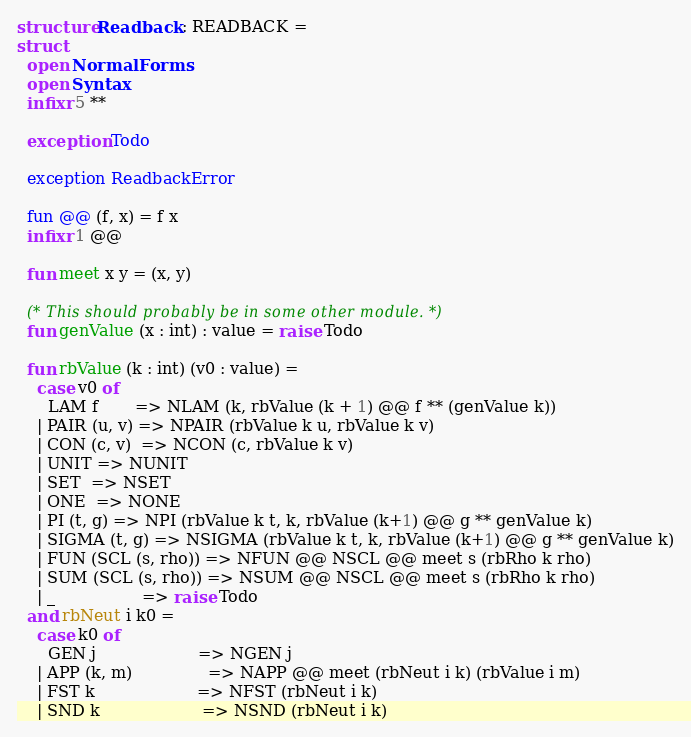<code> <loc_0><loc_0><loc_500><loc_500><_SML_>structure Readback : READBACK =
struct
  open NormalForms
  open Syntax
  infixr 5 **

  exception Todo

  exception ReadbackError

  fun @@ (f, x) = f x
  infixr 1 @@

  fun meet x y = (x, y)

  (* This should probably be in some other module. *)
  fun genValue (x : int) : value = raise Todo

  fun rbValue (k : int) (v0 : value) =
    case v0 of
      LAM f       => NLAM (k, rbValue (k + 1) @@ f ** (genValue k))
    | PAIR (u, v) => NPAIR (rbValue k u, rbValue k v)
    | CON (c, v)  => NCON (c, rbValue k v)
    | UNIT => NUNIT
    | SET  => NSET
    | ONE  => NONE
    | PI (t, g) => NPI (rbValue k t, k, rbValue (k+1) @@ g ** genValue k)
    | SIGMA (t, g) => NSIGMA (rbValue k t, k, rbValue (k+1) @@ g ** genValue k)
    | FUN (SCL (s, rho)) => NFUN @@ NSCL @@ meet s (rbRho k rho)
    | SUM (SCL (s, rho)) => NSUM @@ NSCL @@ meet s (rbRho k rho)
    | _                 => raise Todo
  and rbNeut i k0 =
    case k0 of
      GEN j                    => NGEN j
    | APP (k, m)               => NAPP @@ meet (rbNeut i k) (rbValue i m)
    | FST k                    => NFST (rbNeut i k)
    | SND k                    => NSND (rbNeut i k)</code> 